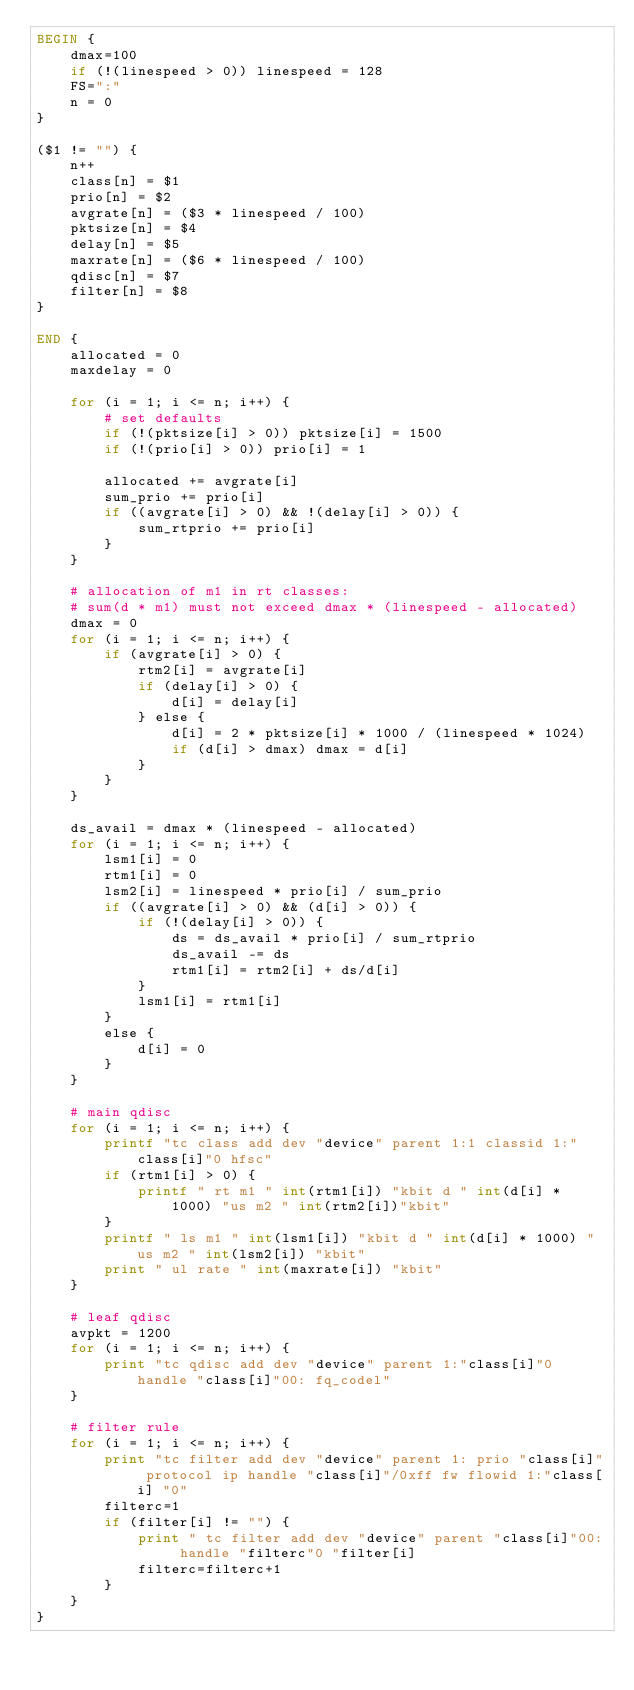Convert code to text. <code><loc_0><loc_0><loc_500><loc_500><_Awk_>BEGIN {
	dmax=100
	if (!(linespeed > 0)) linespeed = 128
	FS=":"
	n = 0
}

($1 != "") {
	n++
	class[n] = $1
	prio[n] = $2
	avgrate[n] = ($3 * linespeed / 100)
	pktsize[n] = $4
	delay[n] = $5
	maxrate[n] = ($6 * linespeed / 100)
	qdisc[n] = $7
	filter[n] = $8
}

END {
	allocated = 0
	maxdelay = 0

	for (i = 1; i <= n; i++) {
		# set defaults
		if (!(pktsize[i] > 0)) pktsize[i] = 1500
		if (!(prio[i] > 0)) prio[i] = 1

		allocated += avgrate[i]
		sum_prio += prio[i]
		if ((avgrate[i] > 0) && !(delay[i] > 0)) {
			sum_rtprio += prio[i]
		}
	}
	
	# allocation of m1 in rt classes:
	# sum(d * m1) must not exceed dmax * (linespeed - allocated)
	dmax = 0
	for (i = 1; i <= n; i++) {
		if (avgrate[i] > 0) {
			rtm2[i] = avgrate[i]
			if (delay[i] > 0) {
				d[i] = delay[i]
			} else {
				d[i] = 2 * pktsize[i] * 1000 / (linespeed * 1024)
				if (d[i] > dmax) dmax = d[i]
			}
		}
	}	

	ds_avail = dmax * (linespeed - allocated)
	for (i = 1; i <= n; i++) {
		lsm1[i] = 0
		rtm1[i] = 0
		lsm2[i] = linespeed * prio[i] / sum_prio
		if ((avgrate[i] > 0) && (d[i] > 0)) {
			if (!(delay[i] > 0)) {
				ds = ds_avail * prio[i] / sum_rtprio
				ds_avail -= ds
				rtm1[i] = rtm2[i] + ds/d[i]
			}
			lsm1[i] = rtm1[i]
		}
		else {
			d[i] = 0
		}
	}

	# main qdisc
	for (i = 1; i <= n; i++) {
		printf "tc class add dev "device" parent 1:1 classid 1:"class[i]"0 hfsc"
		if (rtm1[i] > 0) {
			printf " rt m1 " int(rtm1[i]) "kbit d " int(d[i] * 1000) "us m2 " int(rtm2[i])"kbit"
		}
		printf " ls m1 " int(lsm1[i]) "kbit d " int(d[i] * 1000) "us m2 " int(lsm2[i]) "kbit"
		print " ul rate " int(maxrate[i]) "kbit"
	}

	# leaf qdisc
	avpkt = 1200
	for (i = 1; i <= n; i++) {
		print "tc qdisc add dev "device" parent 1:"class[i]"0 handle "class[i]"00: fq_codel"
	}

	# filter rule
	for (i = 1; i <= n; i++) {
		print "tc filter add dev "device" parent 1: prio "class[i]" protocol ip handle "class[i]"/0xff fw flowid 1:"class[i] "0" 
		filterc=1
		if (filter[i] != "") {
			print " tc filter add dev "device" parent "class[i]"00: handle "filterc"0 "filter[i]
			filterc=filterc+1
		}
	}
}

</code> 